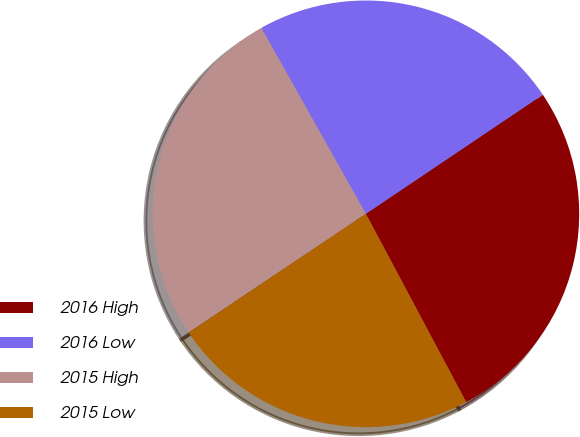<chart> <loc_0><loc_0><loc_500><loc_500><pie_chart><fcel>2016 High<fcel>2016 Low<fcel>2015 High<fcel>2015 Low<nl><fcel>26.64%<fcel>23.72%<fcel>26.23%<fcel>23.4%<nl></chart> 